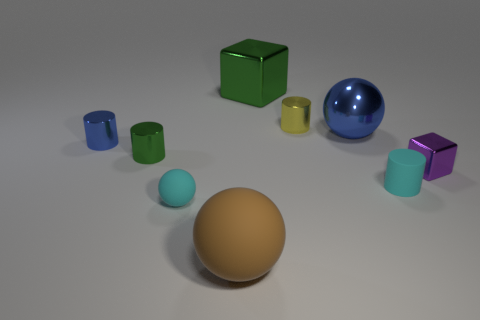What number of objects are metallic blocks that are in front of the green cube or tiny blue metallic cylinders?
Keep it short and to the point. 2. There is a large green thing that is the same material as the tiny purple cube; what shape is it?
Provide a short and direct response. Cube. There is a small yellow thing; what shape is it?
Offer a terse response. Cylinder. What is the color of the large thing that is in front of the big cube and behind the tiny cyan ball?
Offer a terse response. Blue. What is the shape of the purple metallic object that is the same size as the green metallic cylinder?
Offer a very short reply. Cube. Is there a gray shiny thing that has the same shape as the yellow thing?
Your answer should be very brief. No. Does the tiny cyan cylinder have the same material as the cyan object that is in front of the small matte cylinder?
Offer a terse response. Yes. There is a large metal thing that is to the left of the shiny cylinder that is to the right of the green metallic object on the left side of the large green thing; what color is it?
Your answer should be compact. Green. What material is the green thing that is the same size as the blue ball?
Make the answer very short. Metal. What number of yellow cylinders have the same material as the small green cylinder?
Make the answer very short. 1. 